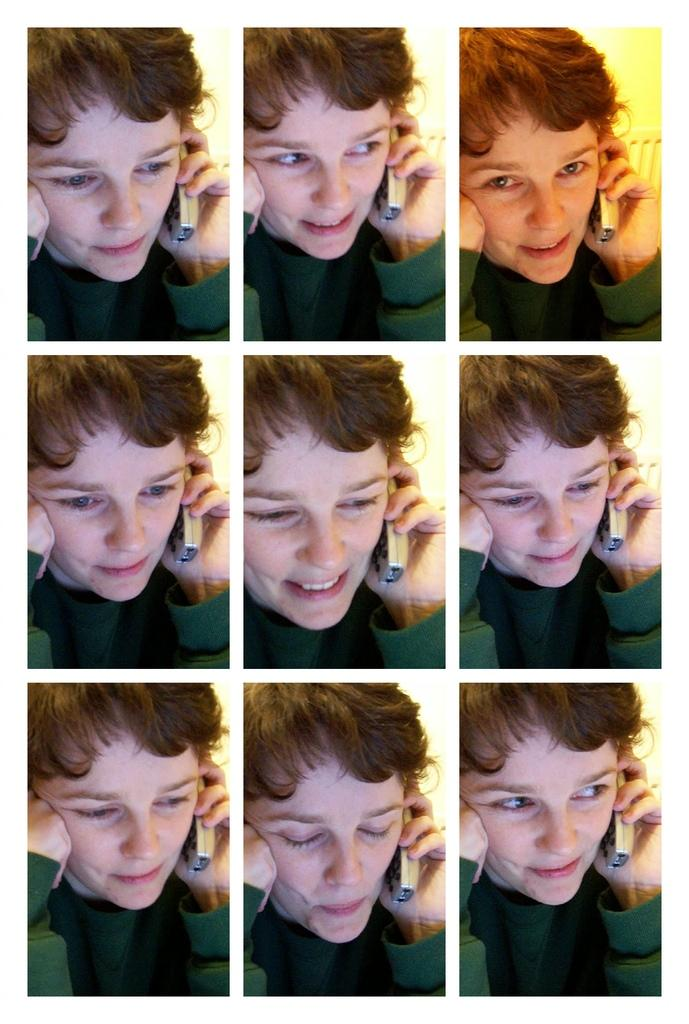What is the main subject of the image? There is a person in the image. What is the person holding in the image? The person is holding a mobile. What is the person's facial expression in the image? The person is smiling. Can you see the person's father in the image? There is no mention of the person's father in the image, so it cannot be determined if they are present. 